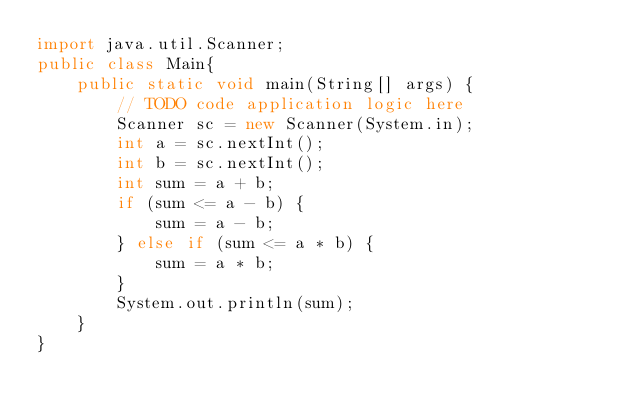<code> <loc_0><loc_0><loc_500><loc_500><_Java_>import java.util.Scanner;
public class Main{
    public static void main(String[] args) {
        // TODO code application logic here
        Scanner sc = new Scanner(System.in);
        int a = sc.nextInt();
        int b = sc.nextInt();
        int sum = a + b;
        if (sum <= a - b) {
            sum = a - b;
        } else if (sum <= a * b) {
            sum = a * b;
        }
        System.out.println(sum);
    }
}
</code> 